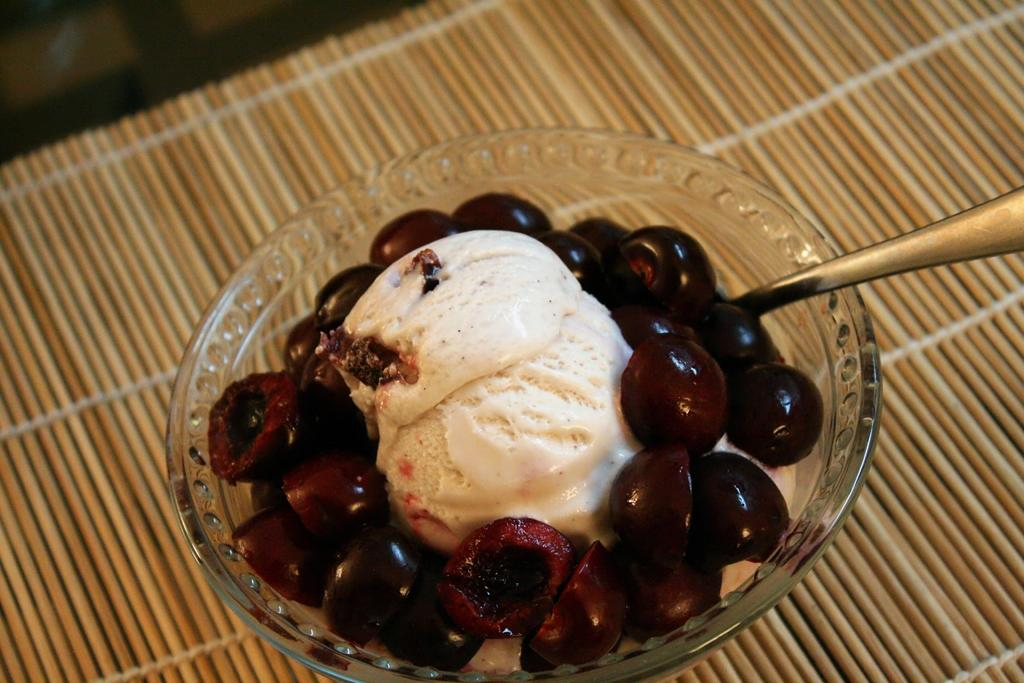What is in the bowl that is visible in the image? There is a bowl with food items in the image. What utensil is visible in the image? There is a spoon visible in the image. What type of hat is being worn by the food in the image? There is no hat present in the image, as the image features a bowl of food items and a spoon. 